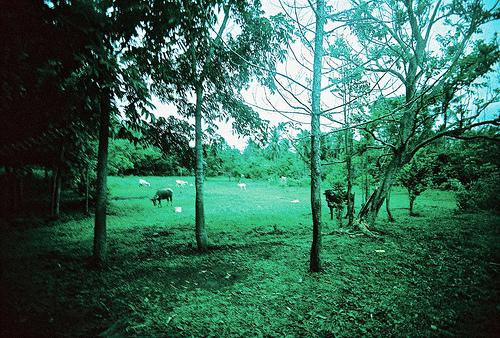Question: what color are the plants?
Choices:
A. Brown.
B. Yellow.
C. Green.
D. Tan.
Answer with the letter. Answer: C Question: what type of scene is this?
Choices:
A. Outdoor.
B. Night.
C. Indoor.
D. Hospital.
Answer with the letter. Answer: A Question: what is cast?
Choices:
A. A glare.
B. A stone.
C. A beam of light.
D. Shadow.
Answer with the letter. Answer: D Question: what are also seen?
Choices:
A. Trees.
B. Insects.
C. Animals.
D. Cars.
Answer with the letter. Answer: C 